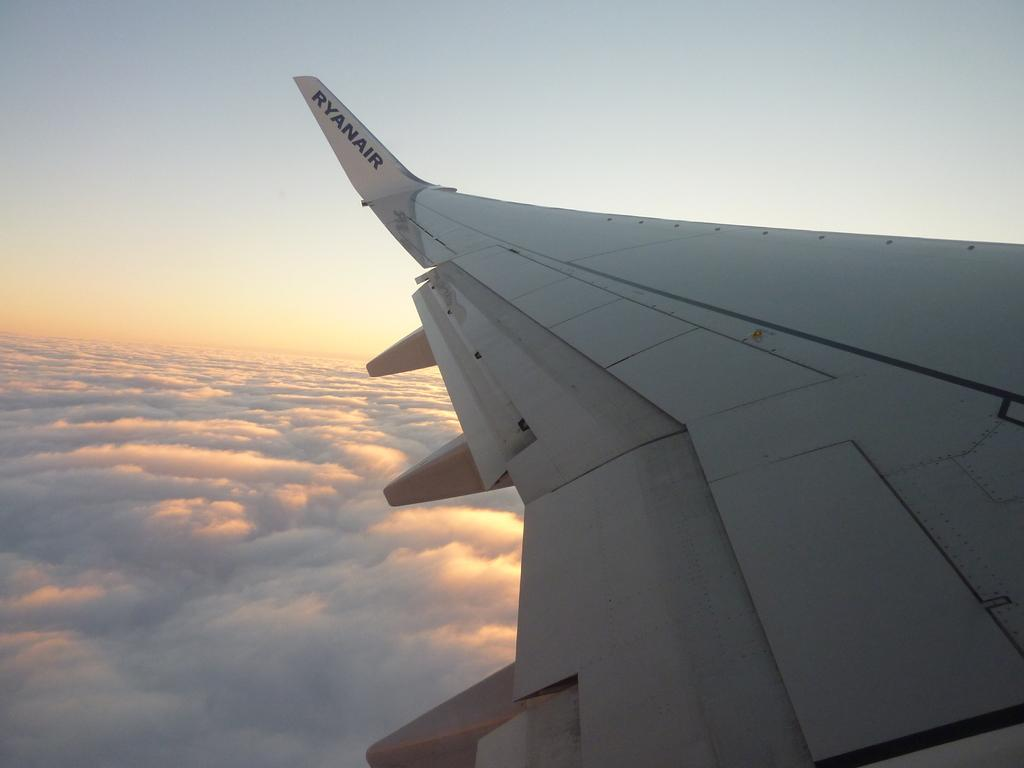What part of an airplane can be seen in the image? The wing of an airplane is visible in the image. What is the airplane doing in the image? The airplane appears to be flying. What can be seen in the sky in the image? There are clouds in the sky in the image. Can you tell me how the guide is gripping the ground in the image? There is no guide or any reference to gripping the ground in the image; it features the wing of an airplane and clouds in the sky. 